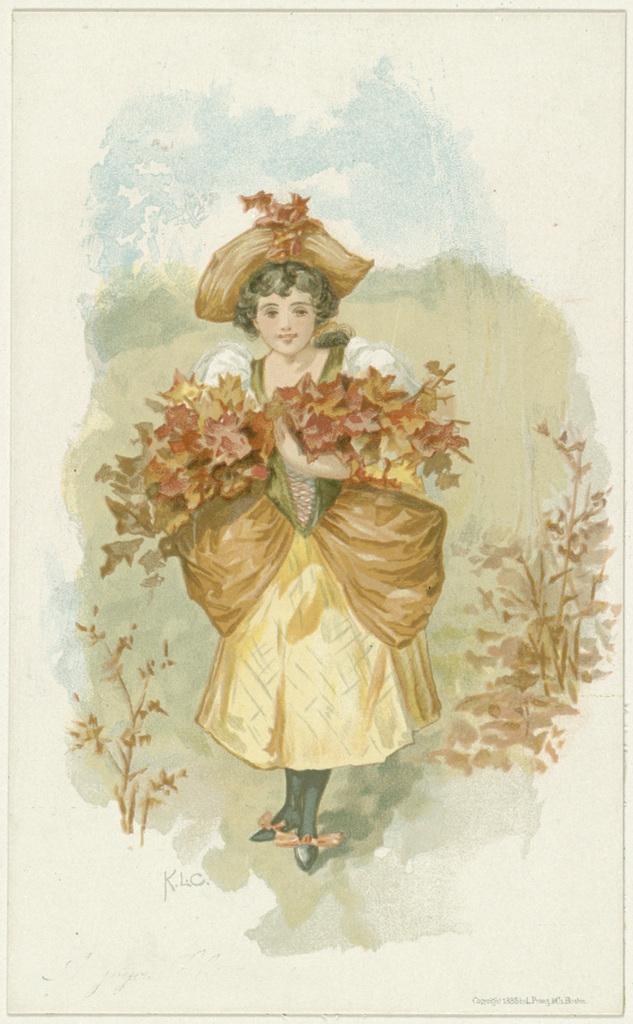Please provide a concise description of this image. This is a painting of a girl holding some flowers. She is wearing a hat. There are plants on either sides of the painting. 